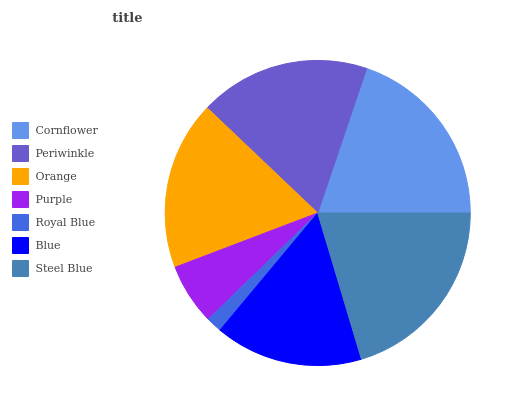Is Royal Blue the minimum?
Answer yes or no. Yes. Is Steel Blue the maximum?
Answer yes or no. Yes. Is Periwinkle the minimum?
Answer yes or no. No. Is Periwinkle the maximum?
Answer yes or no. No. Is Cornflower greater than Periwinkle?
Answer yes or no. Yes. Is Periwinkle less than Cornflower?
Answer yes or no. Yes. Is Periwinkle greater than Cornflower?
Answer yes or no. No. Is Cornflower less than Periwinkle?
Answer yes or no. No. Is Orange the high median?
Answer yes or no. Yes. Is Orange the low median?
Answer yes or no. Yes. Is Royal Blue the high median?
Answer yes or no. No. Is Purple the low median?
Answer yes or no. No. 